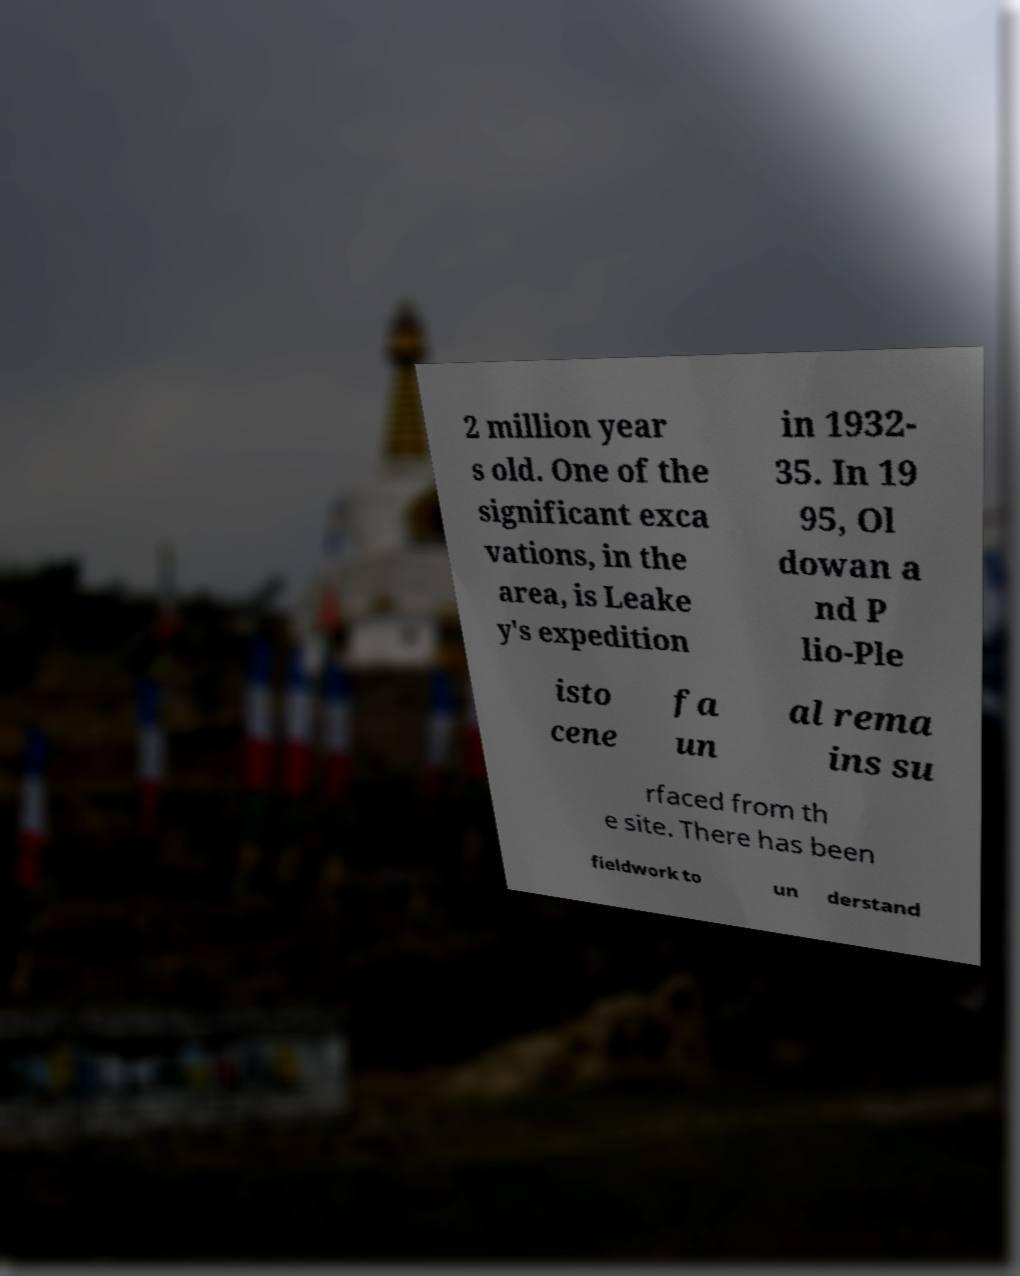Please identify and transcribe the text found in this image. 2 million year s old. One of the significant exca vations, in the area, is Leake y's expedition in 1932- 35. In 19 95, Ol dowan a nd P lio-Ple isto cene fa un al rema ins su rfaced from th e site. There has been fieldwork to un derstand 